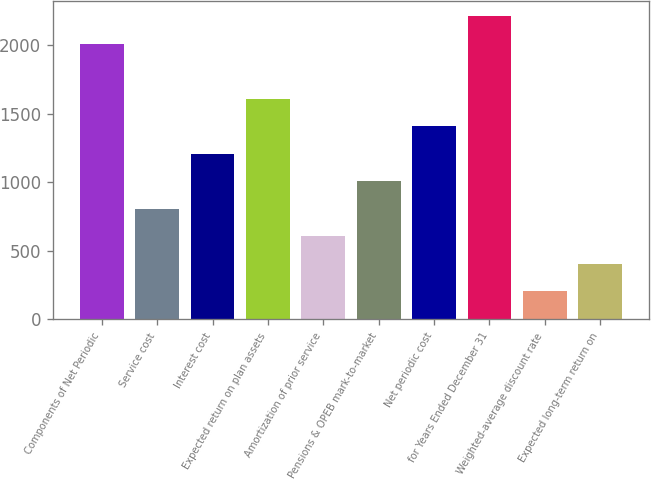<chart> <loc_0><loc_0><loc_500><loc_500><bar_chart><fcel>Components of Net Periodic<fcel>Service cost<fcel>Interest cost<fcel>Expected return on plan assets<fcel>Amortization of prior service<fcel>Pensions & OPEB mark-to-market<fcel>Net periodic cost<fcel>for Years Ended December 31<fcel>Weighted-average discount rate<fcel>Expected long-term return on<nl><fcel>2010<fcel>807.12<fcel>1208.08<fcel>1609.04<fcel>606.64<fcel>1007.6<fcel>1408.56<fcel>2210.48<fcel>205.68<fcel>406.16<nl></chart> 